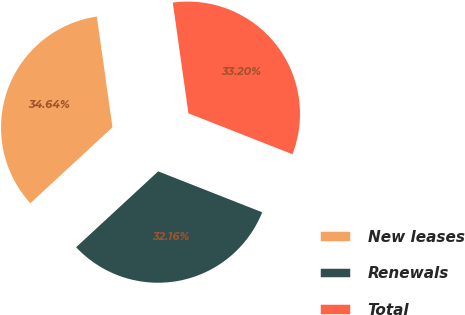<chart> <loc_0><loc_0><loc_500><loc_500><pie_chart><fcel>New leases<fcel>Renewals<fcel>Total<nl><fcel>34.64%<fcel>32.16%<fcel>33.2%<nl></chart> 